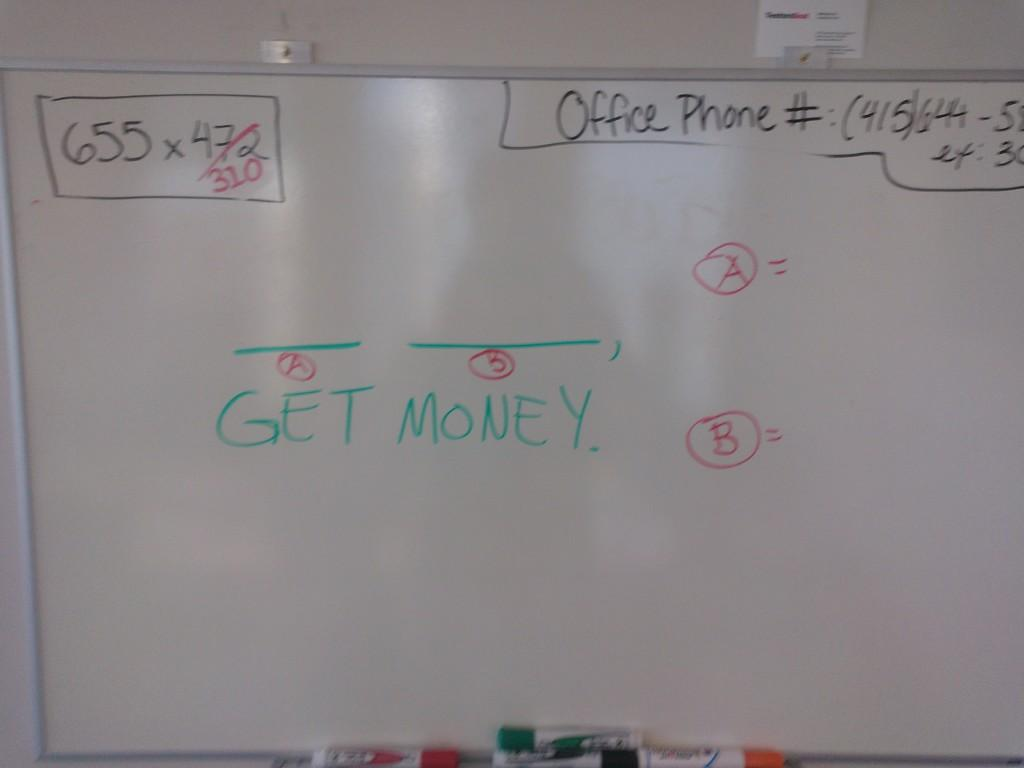Provide a one-sentence caption for the provided image. A white board with several things written on it including a phone number labeled "Office Phone" and the words, "Get Money.". 